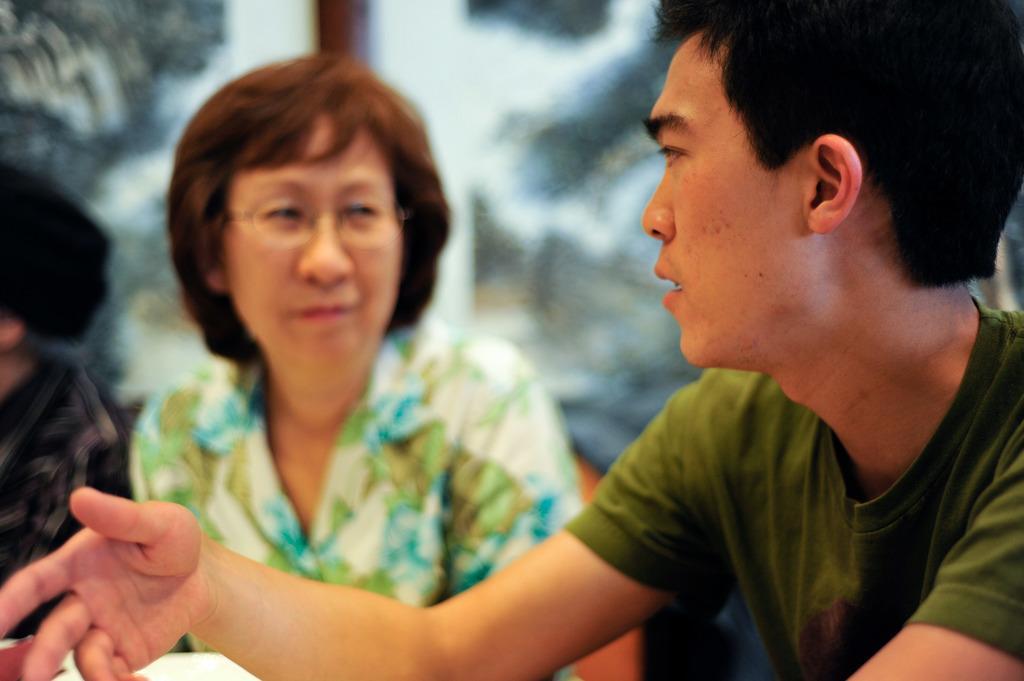In one or two sentences, can you explain what this image depicts? In this picture we can see a man talking and a woman wore a spectacle and in the background it is blur. 